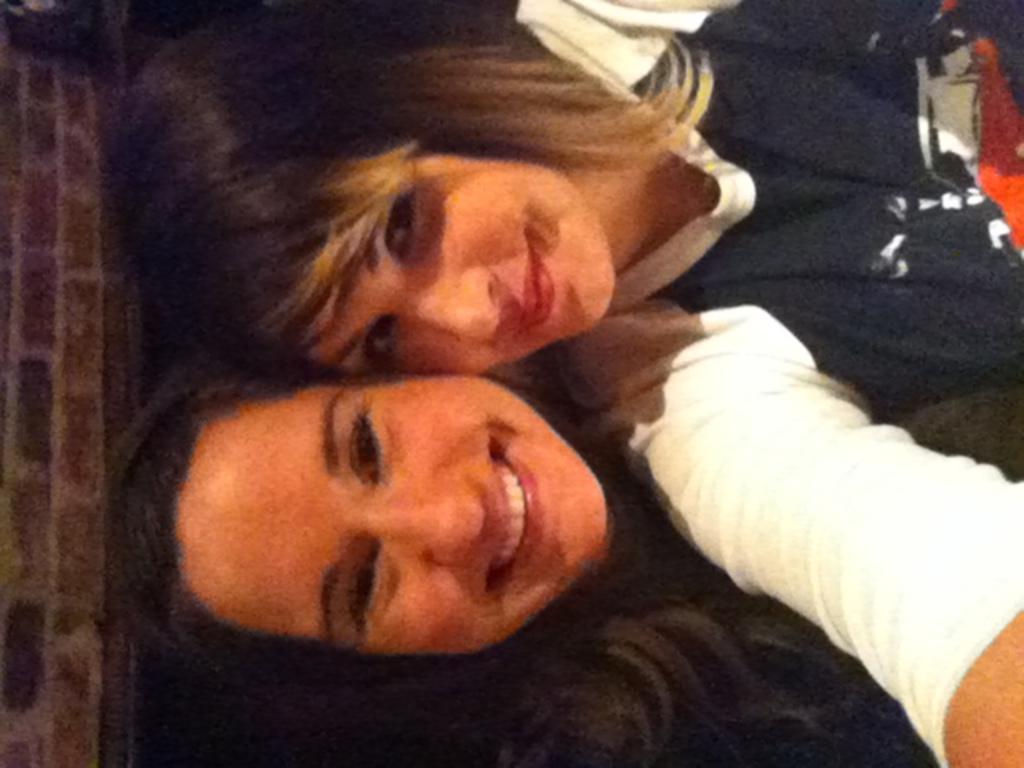How would you summarize this image in a sentence or two? This image is in left direction. Here I can see two women, smiling and giving pose for the picture. On the left side there is a wall. 